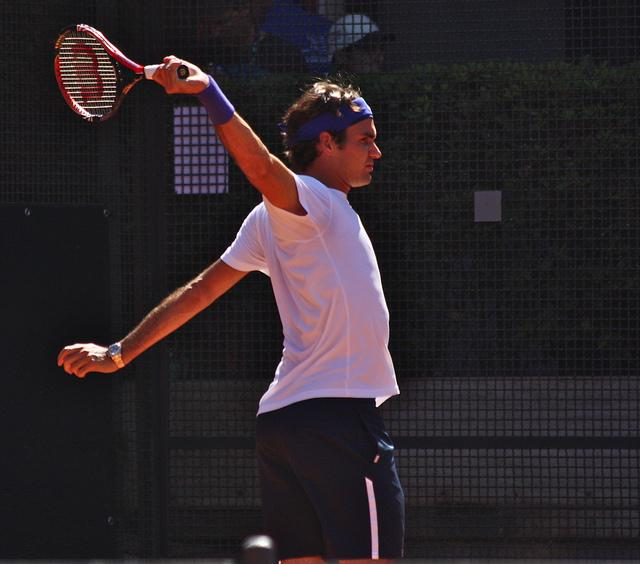What is the silver object on the man's wrist used for? telling time 